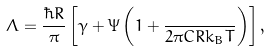Convert formula to latex. <formula><loc_0><loc_0><loc_500><loc_500>\Lambda = \frac { \hbar { R } } { \pi } \left [ \gamma + \Psi \left ( 1 + \frac { } { 2 \pi C R k _ { B } T } \right ) \right ] ,</formula> 